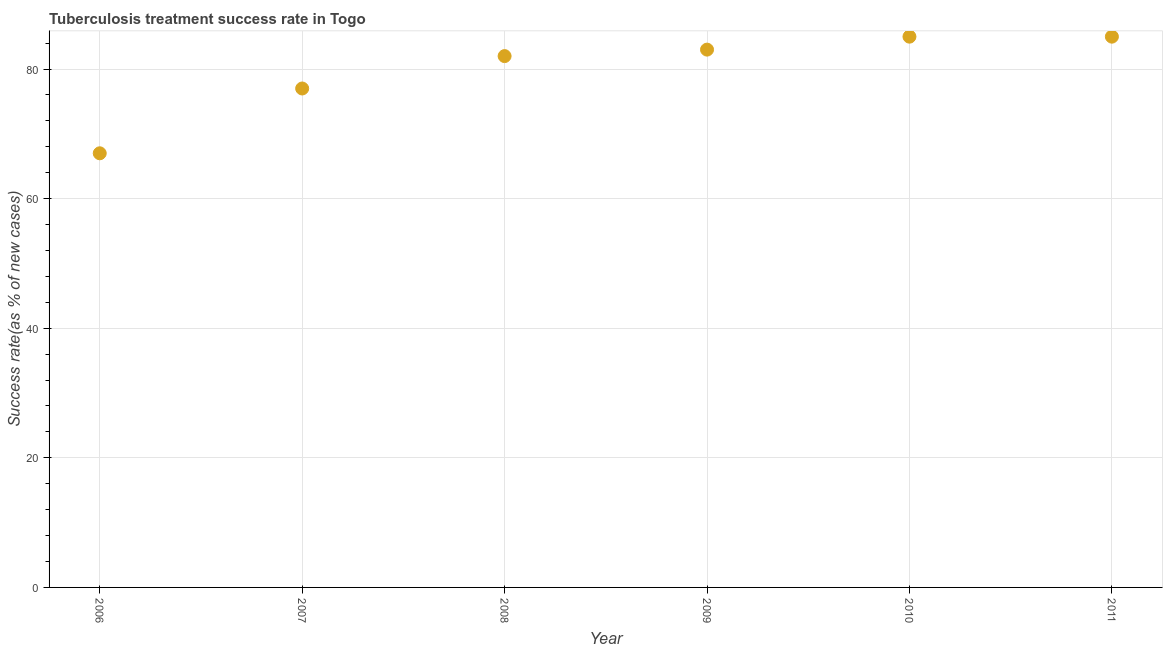What is the tuberculosis treatment success rate in 2009?
Your answer should be very brief. 83. Across all years, what is the maximum tuberculosis treatment success rate?
Offer a very short reply. 85. Across all years, what is the minimum tuberculosis treatment success rate?
Your answer should be compact. 67. In which year was the tuberculosis treatment success rate maximum?
Keep it short and to the point. 2010. What is the sum of the tuberculosis treatment success rate?
Your answer should be very brief. 479. What is the difference between the tuberculosis treatment success rate in 2006 and 2008?
Your answer should be very brief. -15. What is the average tuberculosis treatment success rate per year?
Provide a succinct answer. 79.83. What is the median tuberculosis treatment success rate?
Your answer should be very brief. 82.5. What is the ratio of the tuberculosis treatment success rate in 2008 to that in 2009?
Your answer should be compact. 0.99. Is the difference between the tuberculosis treatment success rate in 2006 and 2009 greater than the difference between any two years?
Your answer should be compact. No. What is the difference between the highest and the second highest tuberculosis treatment success rate?
Your response must be concise. 0. What is the difference between the highest and the lowest tuberculosis treatment success rate?
Make the answer very short. 18. How many dotlines are there?
Make the answer very short. 1. What is the difference between two consecutive major ticks on the Y-axis?
Your response must be concise. 20. Does the graph contain any zero values?
Ensure brevity in your answer.  No. Does the graph contain grids?
Make the answer very short. Yes. What is the title of the graph?
Your answer should be very brief. Tuberculosis treatment success rate in Togo. What is the label or title of the Y-axis?
Make the answer very short. Success rate(as % of new cases). What is the Success rate(as % of new cases) in 2006?
Your answer should be compact. 67. What is the Success rate(as % of new cases) in 2008?
Keep it short and to the point. 82. What is the Success rate(as % of new cases) in 2009?
Ensure brevity in your answer.  83. What is the Success rate(as % of new cases) in 2010?
Ensure brevity in your answer.  85. What is the Success rate(as % of new cases) in 2011?
Provide a succinct answer. 85. What is the difference between the Success rate(as % of new cases) in 2006 and 2008?
Your answer should be very brief. -15. What is the difference between the Success rate(as % of new cases) in 2006 and 2011?
Ensure brevity in your answer.  -18. What is the difference between the Success rate(as % of new cases) in 2007 and 2008?
Provide a succinct answer. -5. What is the difference between the Success rate(as % of new cases) in 2007 and 2010?
Your answer should be very brief. -8. What is the difference between the Success rate(as % of new cases) in 2008 and 2009?
Your answer should be very brief. -1. What is the difference between the Success rate(as % of new cases) in 2008 and 2010?
Provide a short and direct response. -3. What is the difference between the Success rate(as % of new cases) in 2010 and 2011?
Your response must be concise. 0. What is the ratio of the Success rate(as % of new cases) in 2006 to that in 2007?
Ensure brevity in your answer.  0.87. What is the ratio of the Success rate(as % of new cases) in 2006 to that in 2008?
Your answer should be compact. 0.82. What is the ratio of the Success rate(as % of new cases) in 2006 to that in 2009?
Give a very brief answer. 0.81. What is the ratio of the Success rate(as % of new cases) in 2006 to that in 2010?
Provide a short and direct response. 0.79. What is the ratio of the Success rate(as % of new cases) in 2006 to that in 2011?
Keep it short and to the point. 0.79. What is the ratio of the Success rate(as % of new cases) in 2007 to that in 2008?
Provide a succinct answer. 0.94. What is the ratio of the Success rate(as % of new cases) in 2007 to that in 2009?
Your answer should be very brief. 0.93. What is the ratio of the Success rate(as % of new cases) in 2007 to that in 2010?
Ensure brevity in your answer.  0.91. What is the ratio of the Success rate(as % of new cases) in 2007 to that in 2011?
Your answer should be very brief. 0.91. What is the ratio of the Success rate(as % of new cases) in 2008 to that in 2009?
Give a very brief answer. 0.99. What is the ratio of the Success rate(as % of new cases) in 2009 to that in 2011?
Offer a very short reply. 0.98. 